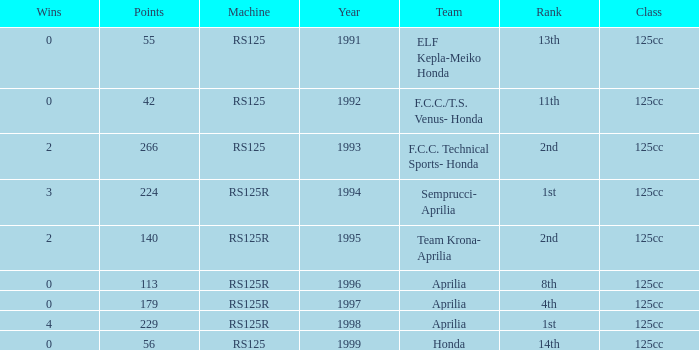Which class had a machine of RS125R, points over 113, and a rank of 4th? 125cc. 